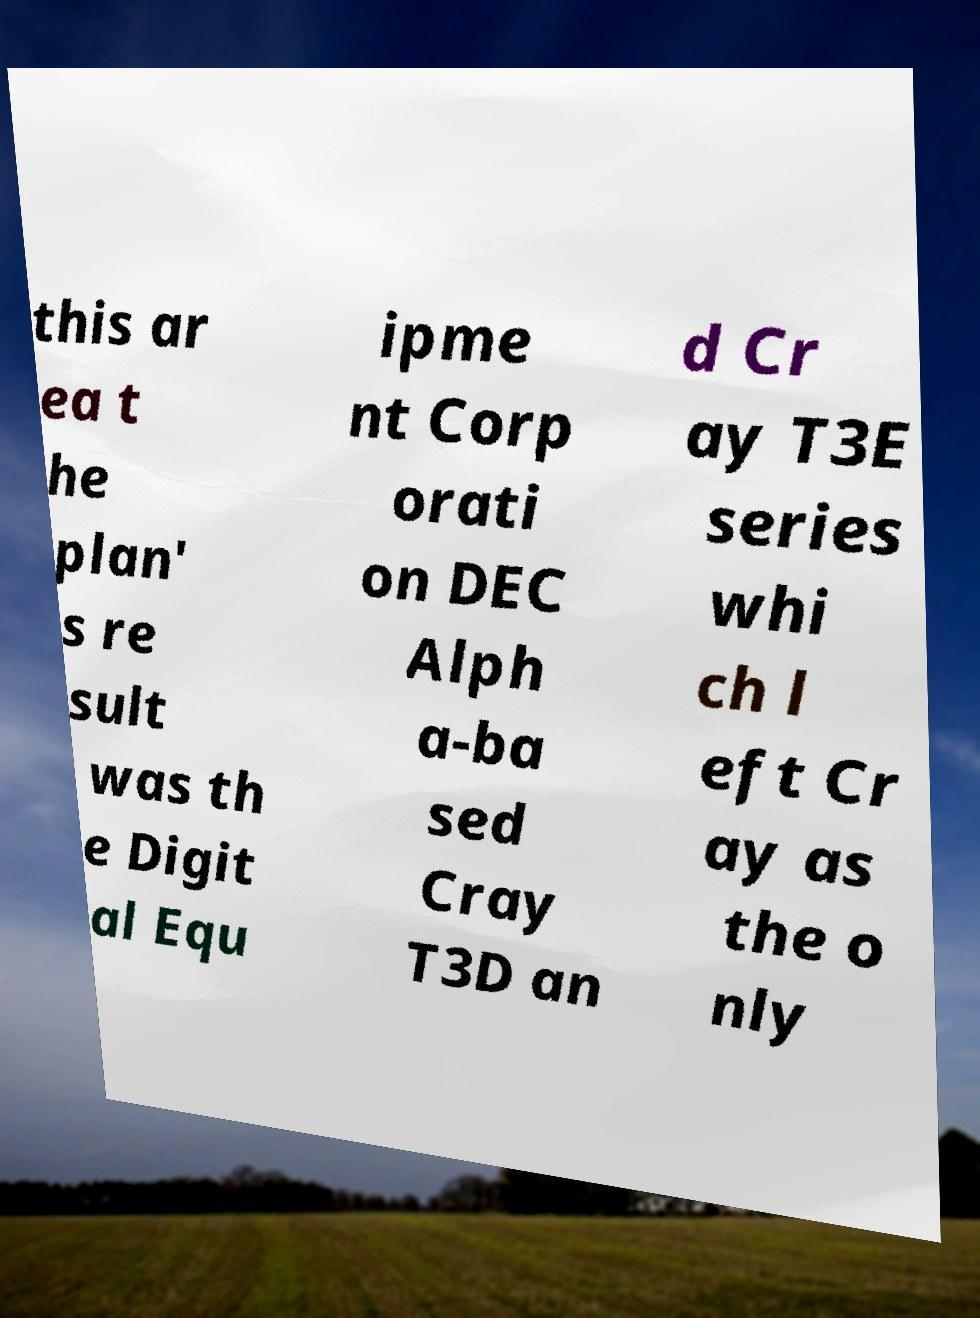Can you read and provide the text displayed in the image?This photo seems to have some interesting text. Can you extract and type it out for me? this ar ea t he plan' s re sult was th e Digit al Equ ipme nt Corp orati on DEC Alph a-ba sed Cray T3D an d Cr ay T3E series whi ch l eft Cr ay as the o nly 